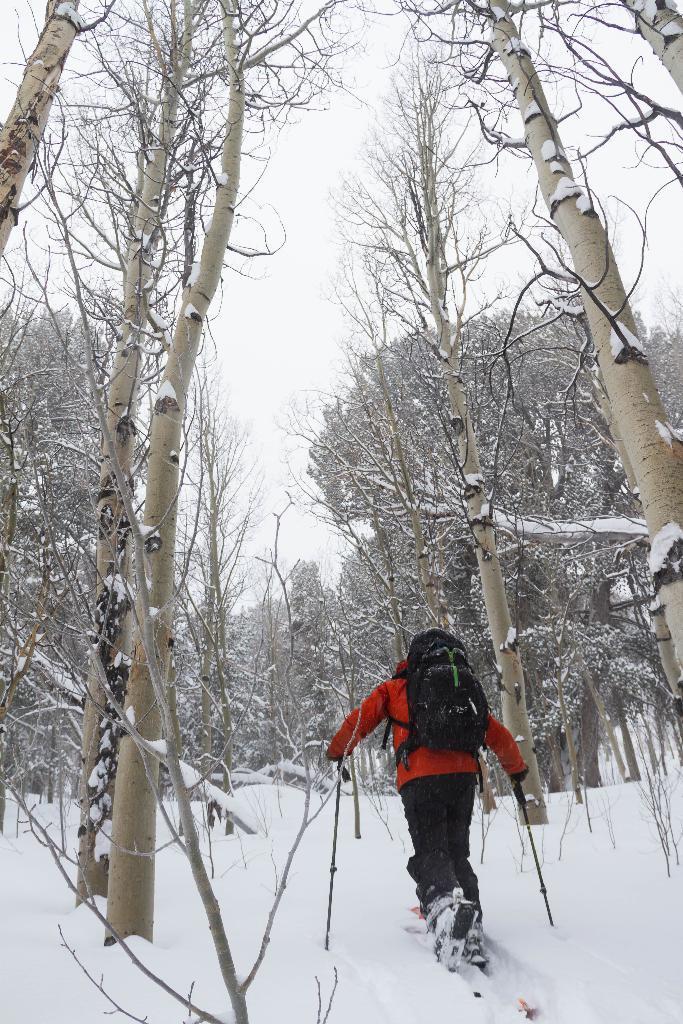Could you give a brief overview of what you see in this image? In this image we can see a person walking on the snow and he is holding the ski sticks in his hands. The person is wearing a red color jacket and he is carrying a bag on the back. Here we can see the trees. 